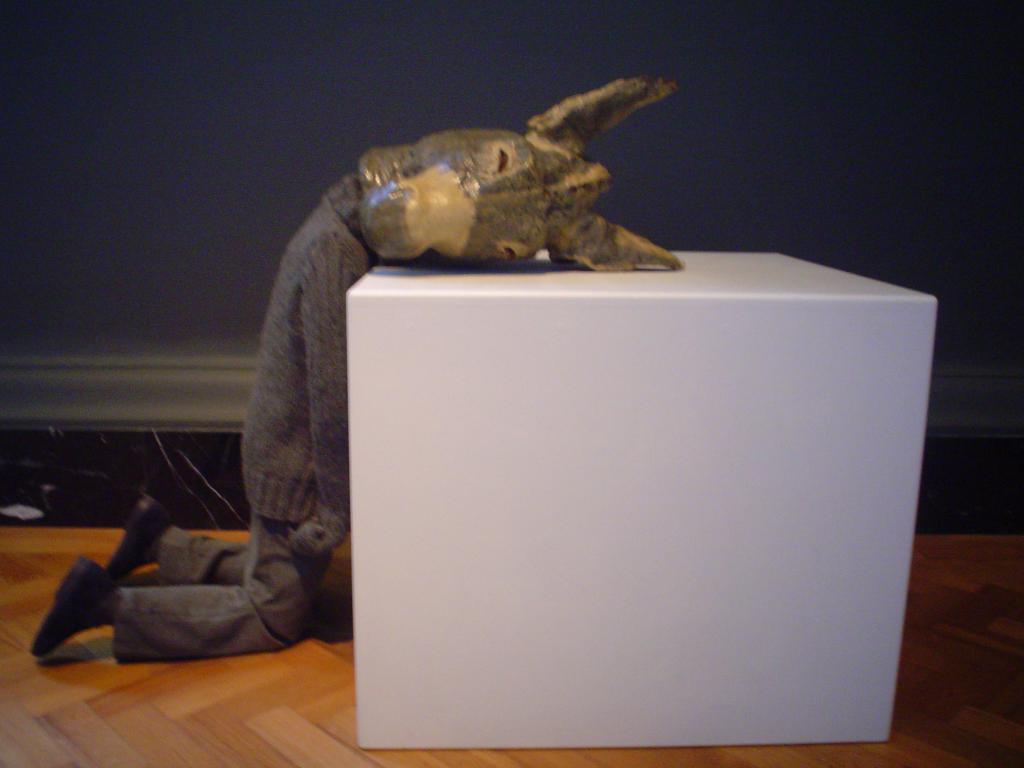How would you summarize this image in a sentence or two? This image is taken indoors. In the background there is a wall. At the bottom of the image there is a floor. In the middle of the image there is cube on the floor. A man is sitting on his knees and he has worn a donkey face mask on his face. 